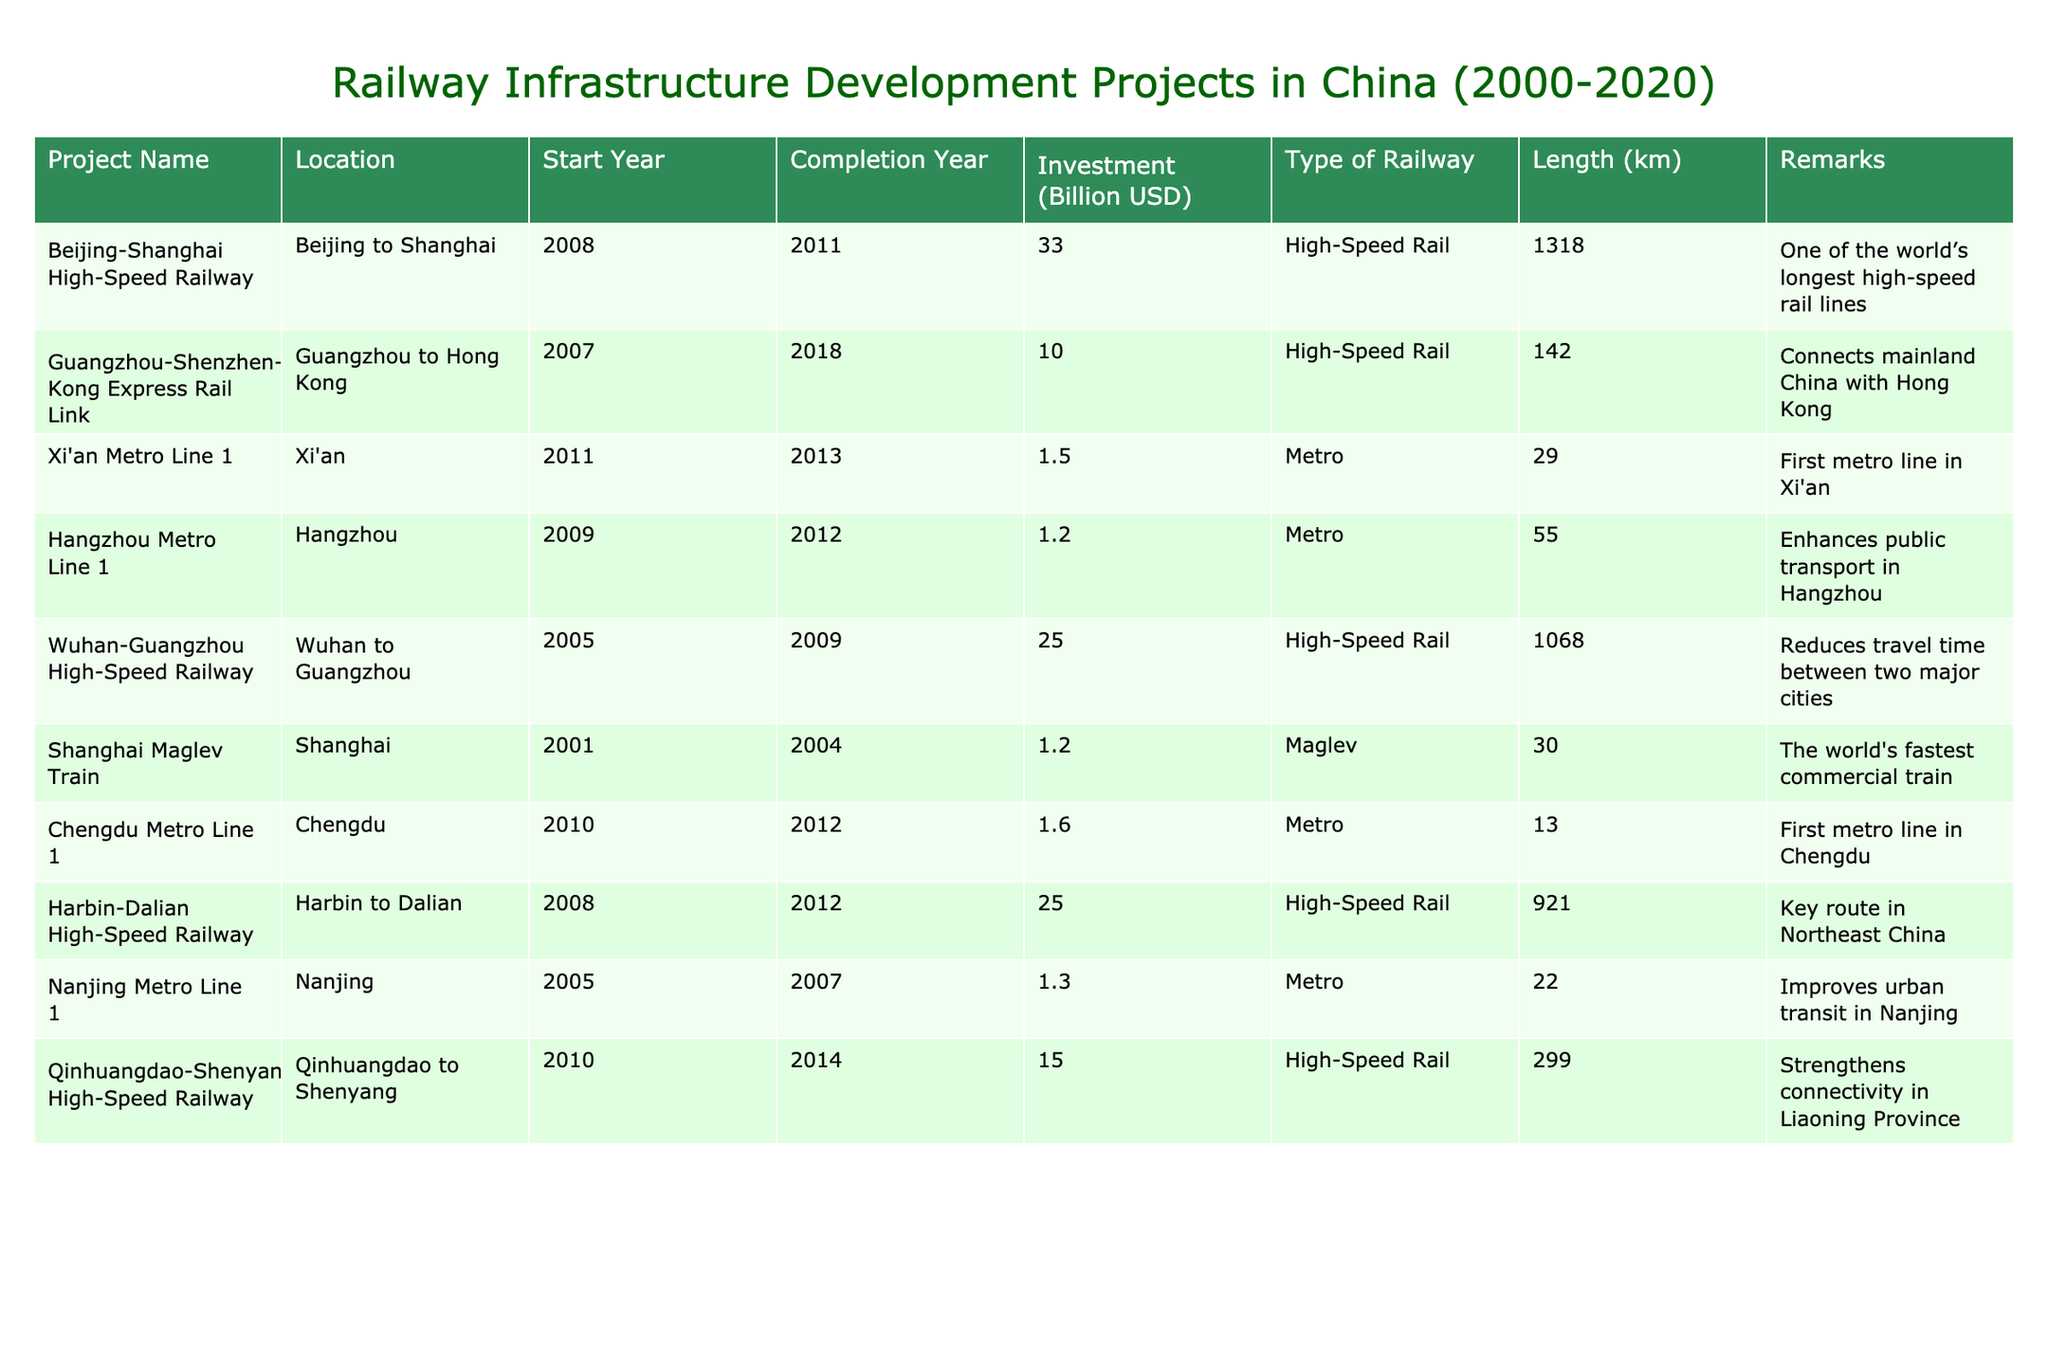What is the total investment for all the high-speed rail projects listed? To find the total investment for high-speed rail projects, we identify the projects categorized under this type: Beijing-Shanghai High-Speed Railway (33.0), Guangzhou-Shenzhen-Hong Kong Express Rail Link (10.0), Wuhan-Guangzhou High-Speed Railway (25.0), Harbin-Dalian High-Speed Railway (25.0), and Qinhuangdao-Shenyang High-Speed Railway (15.0). We sum these values: 33.0 + 10.0 + 25.0 + 25.0 + 15.0 = 108.0 billion USD.
Answer: 108.0 billion USD Which project had the longest length of railway? From the table, the project with the longest length is the Beijing-Shanghai High-Speed Railway, measuring 1318 kilometers. This can be simply observed by comparing the length values from each entry.
Answer: Beijing-Shanghai High-Speed Railway Did the Shanghai Maglev Train have a higher investment than the Hangzhou Metro Line 1? The investment for the Shanghai Maglev Train is 1.2 billion USD, while the Hangzhou Metro Line 1 has an investment of 1.2 billion USD as well. Since they are equal, the answer is no.
Answer: No What is the average length of the metro projects listed in the table? First, identify the metro projects: Xi'an Metro Line 1 (29 km), Hangzhou Metro Line 1 (55 km), Chengdu Metro Line 1 (13 km), and Nanjing Metro Line 1 (22 km). Next, sum the lengths: 29 + 55 + 13 + 22 = 119 km. Since there are 4 metro projects, the average length is calculated as 119 / 4 = 29.75 km.
Answer: 29.75 km Which railway project has the earliest start year? By comparing the start years of all projects, we find that the Shanghai Maglev Train started in 2001, which is the earliest among all listed projects.
Answer: Shanghai Maglev Train Is there a metro project that connects city to city? The Hangzhou Metro Line 1 does not connect cities, it serves metropolitan transit in Hangzhou itself. Other metro lines listed such as Xi'an and Chengdu also serve local areas. Therefore, the answer is no.
Answer: No What percentage of the total investment comes from high-speed rail projects? We already calculated the total investment for high-speed rail projects as 108 billion USD. Now, we find the total investment from all projects: 33 + 10 + 1.5 + 1.2 + 25 + 1.2 + 1.6 + 25 + 1.3 + 15 = 118.8 billion USD. Next, compute the percentage: (108 / 118.8) * 100 ≈ 90.9%.
Answer: Approximately 90.9% Which two metro projects have the highest investment? The projects identified are Xi'an Metro Line 1 with 1.5 billion USD and Chengdu Metro Line 1 with 1.6 billion USD, making these the two projects with the highest investment among the metro lines.
Answer: Chengdu Metro Line 1 and Xi'an Metro Line 1 What is the difference in investment between the Wuhan-Guangzhou High-Speed Railway and the Guangzhou-Shenzhen-Hong Kong Express Rail Link? The investment for the Wuhan-Guangzhou High-Speed Railway is 25.0 billion USD, and for the Guangzhou-Shenzhen-Hong Kong Express Rail Link, it is 10.0 billion USD. So, the investment difference is 25.0 - 10.0 = 15.0 billion USD.
Answer: 15.0 billion USD 